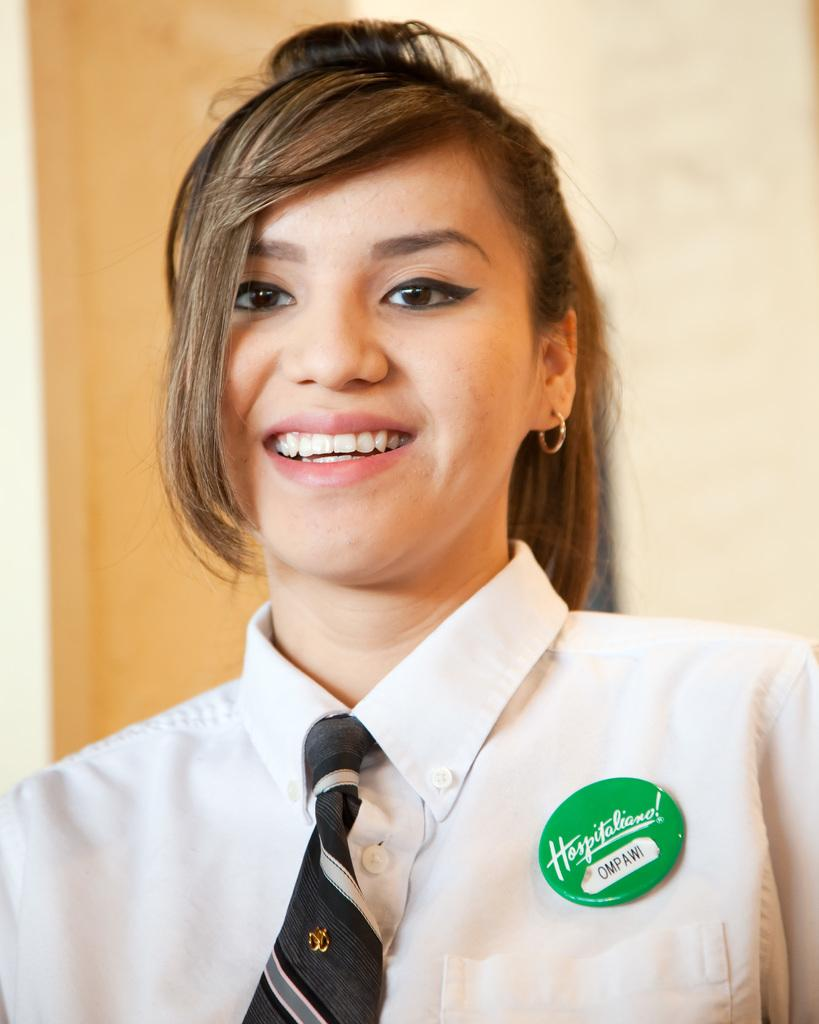<image>
Summarize the visual content of the image. A girl is wearing a white shirt with a green pin that says Ompawi. 